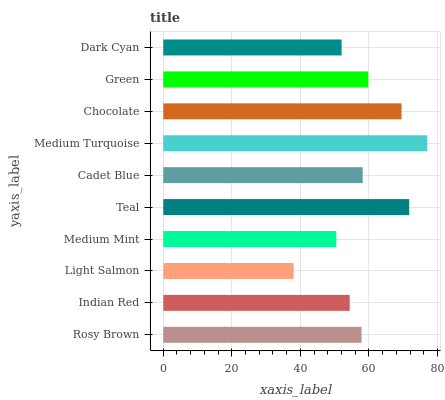Is Light Salmon the minimum?
Answer yes or no. Yes. Is Medium Turquoise the maximum?
Answer yes or no. Yes. Is Indian Red the minimum?
Answer yes or no. No. Is Indian Red the maximum?
Answer yes or no. No. Is Rosy Brown greater than Indian Red?
Answer yes or no. Yes. Is Indian Red less than Rosy Brown?
Answer yes or no. Yes. Is Indian Red greater than Rosy Brown?
Answer yes or no. No. Is Rosy Brown less than Indian Red?
Answer yes or no. No. Is Cadet Blue the high median?
Answer yes or no. Yes. Is Rosy Brown the low median?
Answer yes or no. Yes. Is Rosy Brown the high median?
Answer yes or no. No. Is Chocolate the low median?
Answer yes or no. No. 